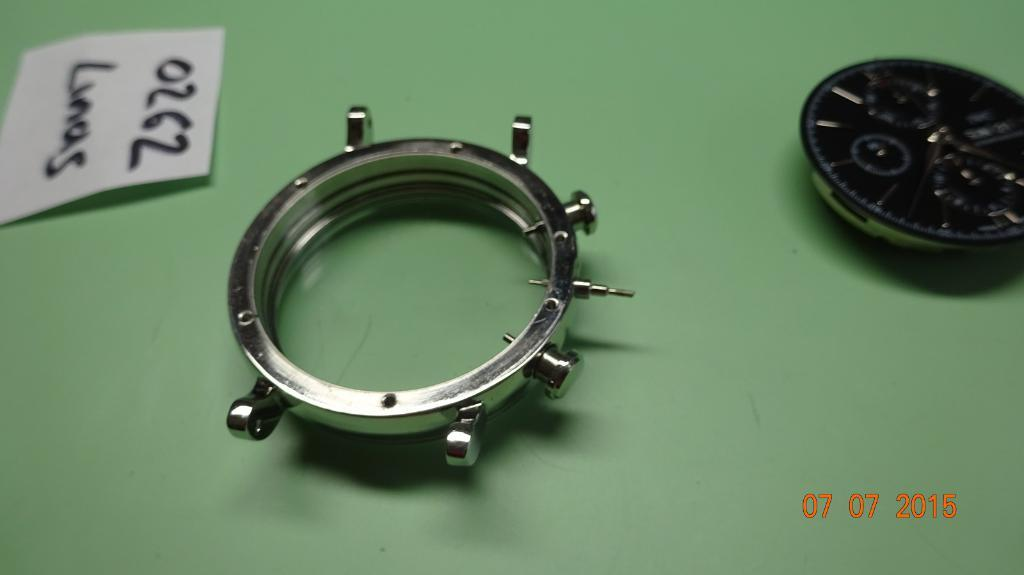<image>
Summarize the visual content of the image. A label reading 0262 Linas is on a green table along with the inside watch face and the metal ring that goes around it. 